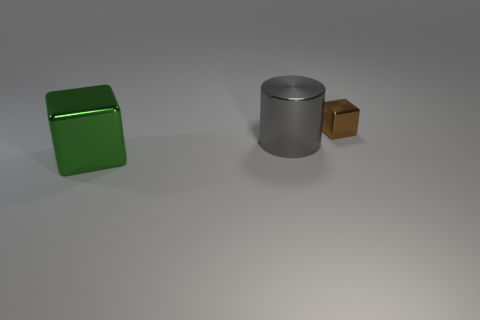Add 3 big gray metal objects. How many objects exist? 6 Subtract all blocks. How many objects are left? 1 Subtract all tiny rubber things. Subtract all small objects. How many objects are left? 2 Add 3 large metallic things. How many large metallic things are left? 5 Add 2 yellow shiny objects. How many yellow shiny objects exist? 2 Subtract 0 yellow cylinders. How many objects are left? 3 